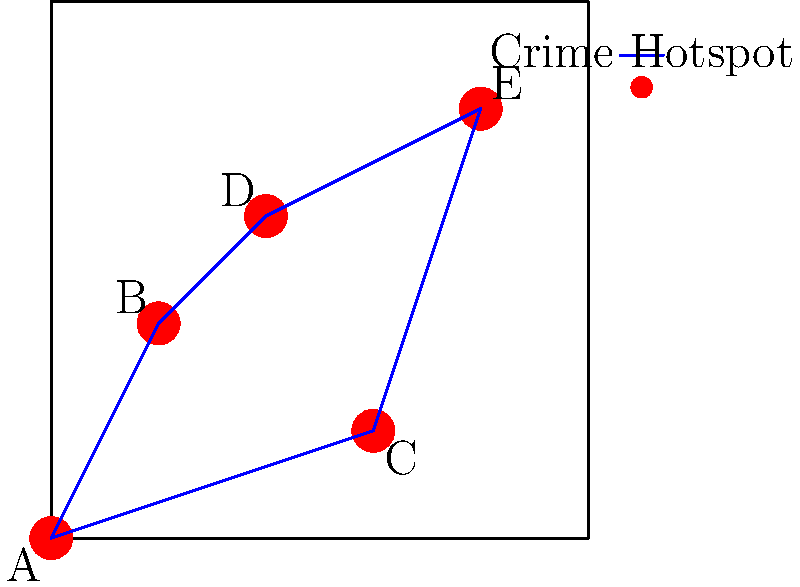Based on the crime hotspot map provided, which area should be prioritized for increased patrols and community outreach programs to reduce gun violence? Consider the network of connections between hotspots and their relative positions. To determine the priority area for increased patrols and community outreach programs, we need to analyze the crime hotspot map using the following steps:

1. Identify the hotspots: The map shows five crime hotspots labeled A, B, C, D, and E.

2. Analyze the network connections:
   - Hotspot D is connected to three other hotspots (B, E, and C).
   - Hotspots B and E are each connected to three other hotspots.
   - Hotspots A and C are each connected to two other hotspots.

3. Consider the central location:
   - Hotspot D appears to be in a more central location compared to the others.

4. Evaluate the potential impact:
   - Focusing on hotspot D would likely have the most significant impact on the overall network of crime hotspots due to its central location and multiple connections.

5. Strategic importance:
   - By prioritizing hotspot D, law enforcement can potentially disrupt criminal activities in the surrounding areas (B, E, and C) more effectively.

6. Resource allocation:
   - Concentrating efforts on hotspot D allows for efficient use of limited resources while potentially affecting a larger area of influence.

Based on this analysis, hotspot D should be prioritized for increased patrols and community outreach programs to reduce gun violence. Its central location and connections to multiple other hotspots make it a strategic choice for intervention.
Answer: Hotspot D 